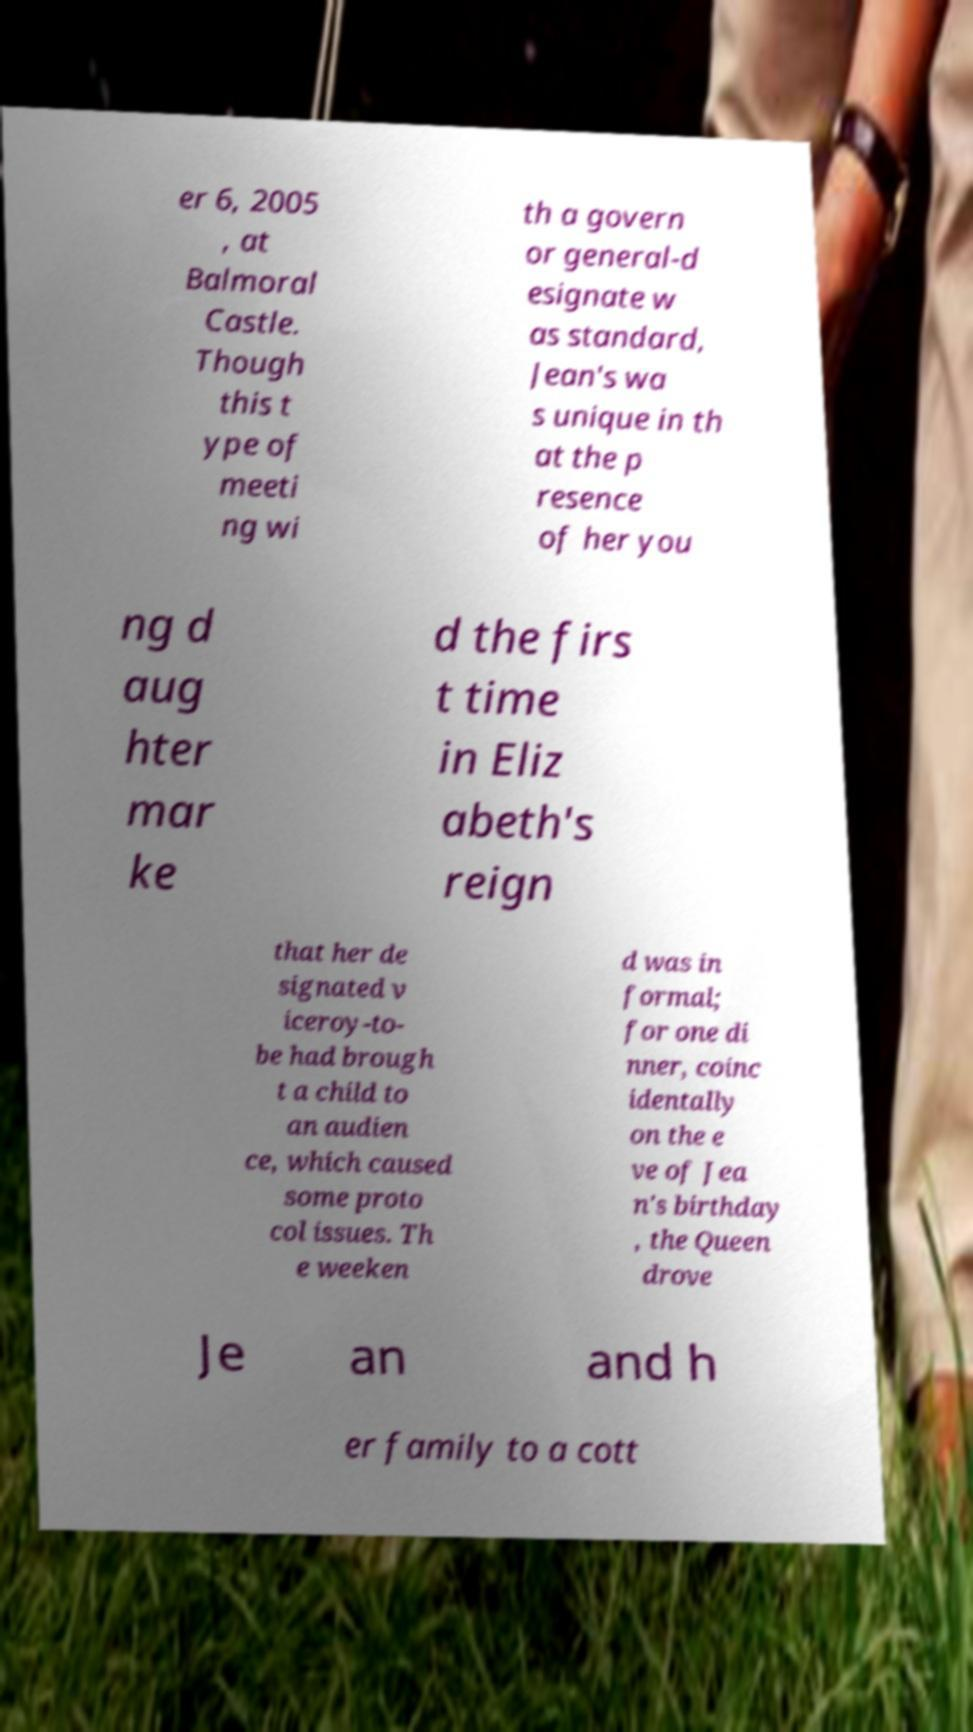Could you assist in decoding the text presented in this image and type it out clearly? er 6, 2005 , at Balmoral Castle. Though this t ype of meeti ng wi th a govern or general-d esignate w as standard, Jean's wa s unique in th at the p resence of her you ng d aug hter mar ke d the firs t time in Eliz abeth's reign that her de signated v iceroy-to- be had brough t a child to an audien ce, which caused some proto col issues. Th e weeken d was in formal; for one di nner, coinc identally on the e ve of Jea n's birthday , the Queen drove Je an and h er family to a cott 